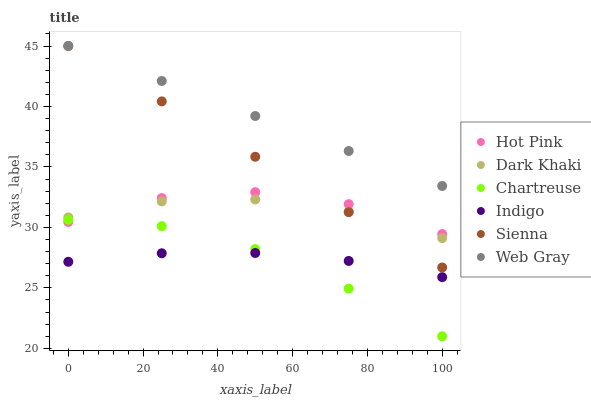Does Chartreuse have the minimum area under the curve?
Answer yes or no. Yes. Does Web Gray have the maximum area under the curve?
Answer yes or no. Yes. Does Indigo have the minimum area under the curve?
Answer yes or no. No. Does Indigo have the maximum area under the curve?
Answer yes or no. No. Is Sienna the smoothest?
Answer yes or no. Yes. Is Hot Pink the roughest?
Answer yes or no. Yes. Is Web Gray the smoothest?
Answer yes or no. No. Is Web Gray the roughest?
Answer yes or no. No. Does Chartreuse have the lowest value?
Answer yes or no. Yes. Does Indigo have the lowest value?
Answer yes or no. No. Does Web Gray have the highest value?
Answer yes or no. Yes. Does Indigo have the highest value?
Answer yes or no. No. Is Dark Khaki less than Web Gray?
Answer yes or no. Yes. Is Dark Khaki greater than Chartreuse?
Answer yes or no. Yes. Does Sienna intersect Web Gray?
Answer yes or no. Yes. Is Sienna less than Web Gray?
Answer yes or no. No. Is Sienna greater than Web Gray?
Answer yes or no. No. Does Dark Khaki intersect Web Gray?
Answer yes or no. No. 